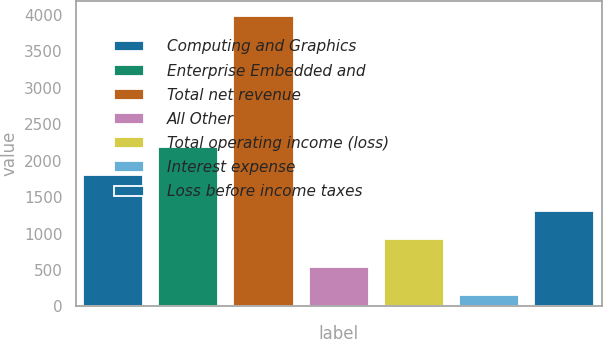<chart> <loc_0><loc_0><loc_500><loc_500><bar_chart><fcel>Computing and Graphics<fcel>Enterprise Embedded and<fcel>Total net revenue<fcel>All Other<fcel>Total operating income (loss)<fcel>Interest expense<fcel>Loss before income taxes<nl><fcel>1805<fcel>2188.1<fcel>3991<fcel>543.1<fcel>926.2<fcel>160<fcel>1309.3<nl></chart> 